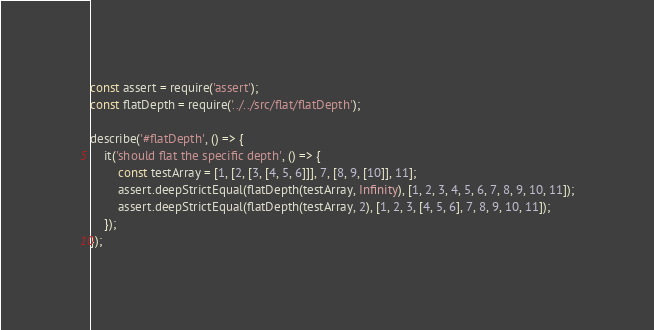<code> <loc_0><loc_0><loc_500><loc_500><_JavaScript_>const assert = require('assert');
const flatDepth = require('../../src/flat/flatDepth');

describe('#flatDepth', () => {
    it('should flat the specific depth', () => {
        const testArray = [1, [2, [3, [4, 5, 6]]], 7, [8, 9, [10]], 11];
        assert.deepStrictEqual(flatDepth(testArray, Infinity), [1, 2, 3, 4, 5, 6, 7, 8, 9, 10, 11]);
        assert.deepStrictEqual(flatDepth(testArray, 2), [1, 2, 3, [4, 5, 6], 7, 8, 9, 10, 11]);
    });
});
</code> 